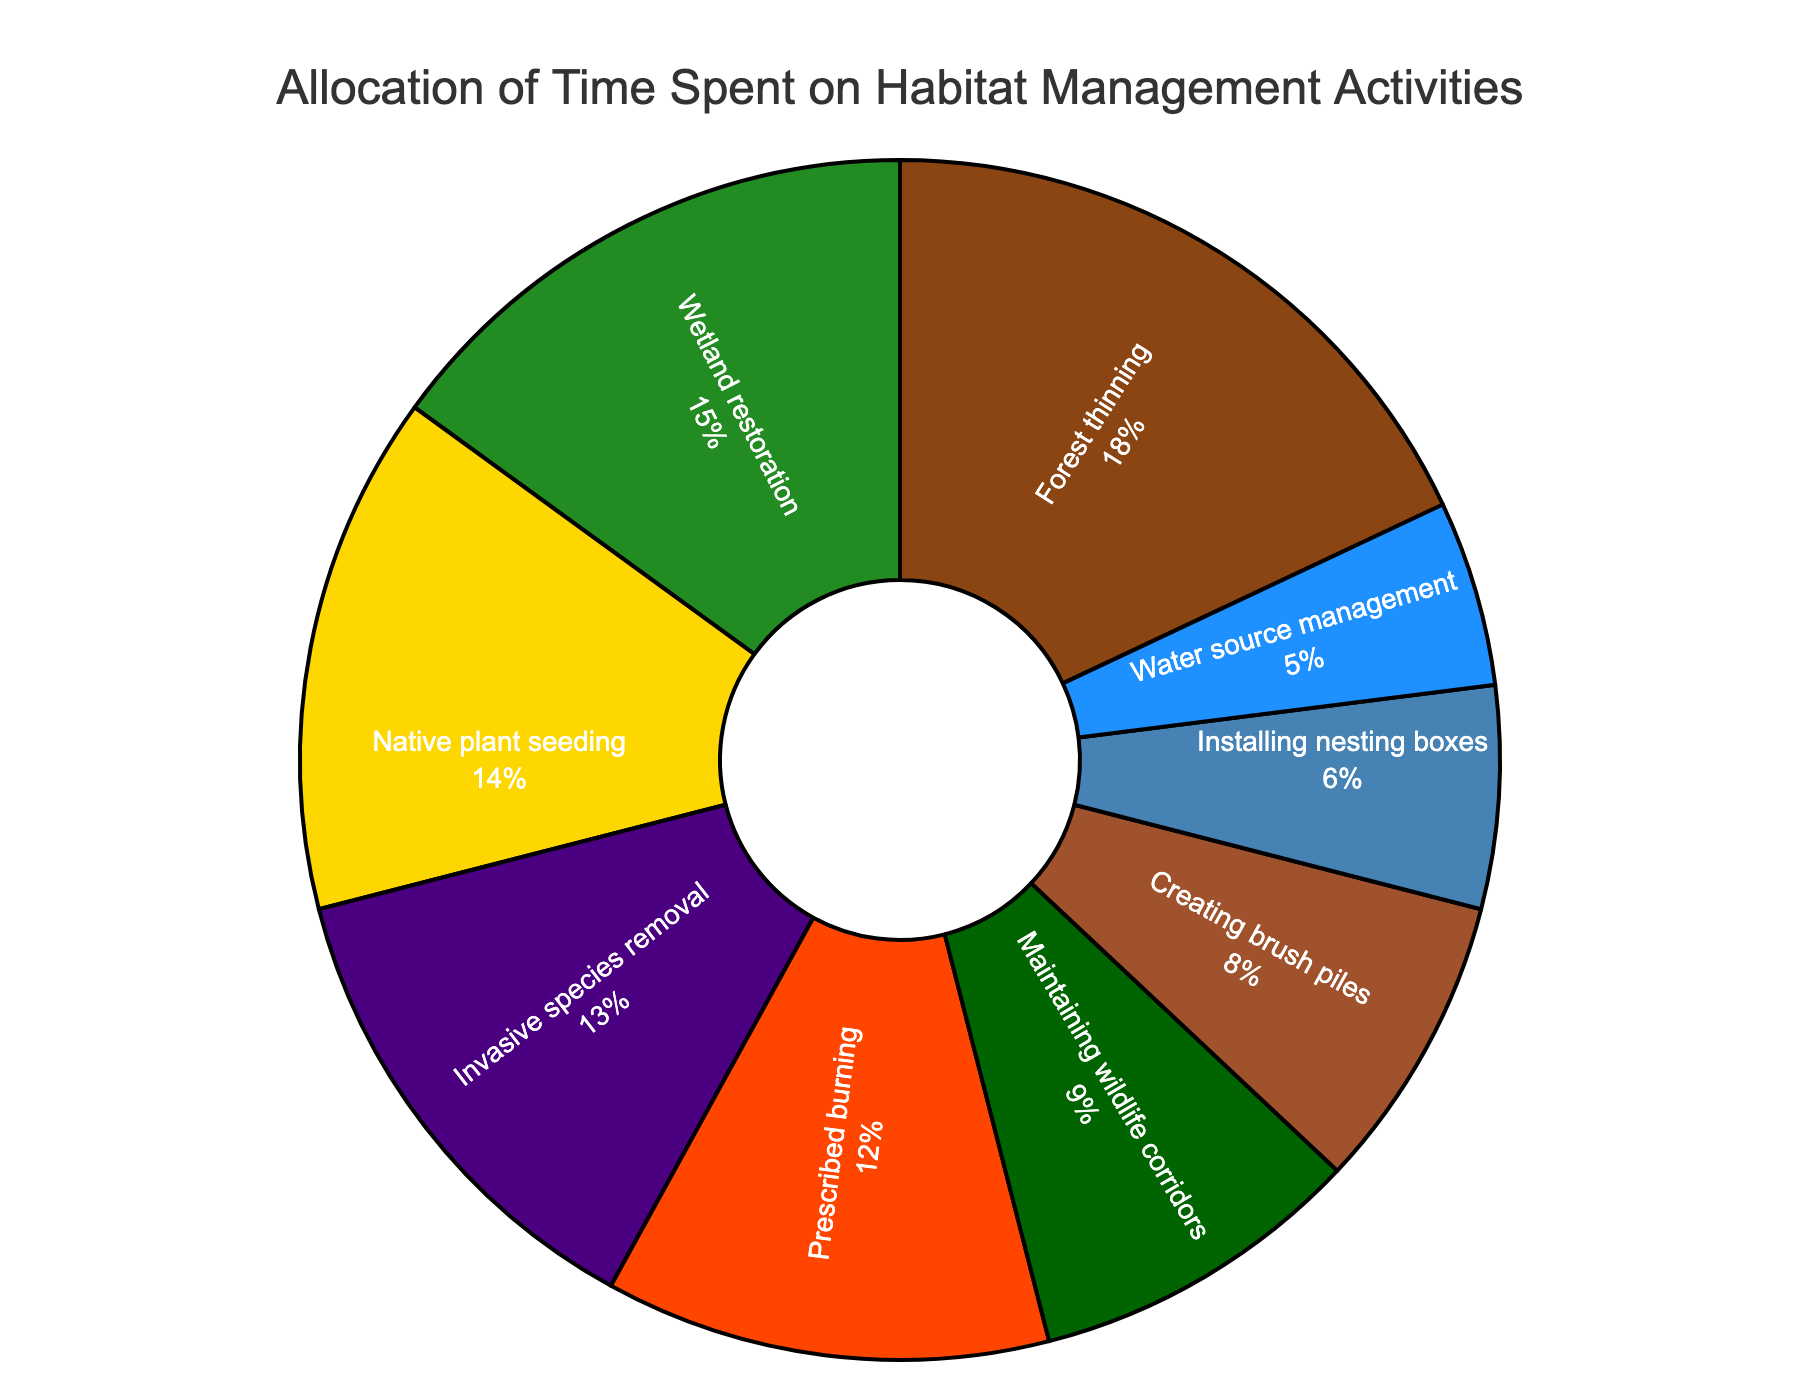What percentage of time is spent on prescribed burning? According to the figure, the percentage of time spent on prescribed burning is indicated visually. Simply read the label next to "Prescribed burning" in the pie chart.
Answer: 12% Which activity consumes the highest percentage of time? Examine the figure to identify the segment of the pie chart that covers the largest area. This segment will correspond to the activity with the highest percentage of time spent.
Answer: Forest thinning How much more time is spent on native plant seeding compared to installing nesting boxes? Check the percentage for both "Native plant seeding" and "Installing nesting boxes" from the pie chart, then subtract the latter from the former: 14% - 6% = 8%.
Answer: 8% What is the combined percentage of time spent on wetland restoration and maintaining wildlife corridors? Identify the percentages for "Wetland restoration" and "Maintaining wildlife corridors" from the pie chart, then add them together: 15% + 9% = 24%.
Answer: 24% Among the listed activities, which one consumes the least amount of time, and what is its percentage? Look for the smallest segment in the pie chart to identify the activity with the lowest percentage. Check the label for its corresponding percentage.
Answer: Water source management, 5% Is the time spent on invasive species removal more or less than that on creating brush piles? Compare the percentage values for "Invasive species removal" and "Creating brush piles" from the pie chart. Invasive species removal is 13%, and creating brush piles is 8%. 13% is greater than 8%.
Answer: More What is the total percentage of time spent on forest thinning, prescribed burning, and native plant seeding? Add up the percentages for "Forest thinning," "Prescribed burning," and "Native plant seeding": 18% + 12% + 14% = 44%.
Answer: 44% Which activity has a visual representation with the color green, and what is its percentage? Observe the segment in the pie chart that is colored green. Identify the activity and its corresponding percentage label from the chart.
Answer: Wetland restoration, 15% How does the percentage of time spent on maintaining wildlife corridors compare to that of installing nesting boxes and creating brush piles combined? First, sum the percentages for "Installing nesting boxes" and "Creating brush piles": 6% + 8% = 14%. Then, compare that to the percentage for "Maintaining wildlife corridors," which is 9%. Since 9% is less than 14%, maintaining wildlife corridors consumes less time.
Answer: Less 